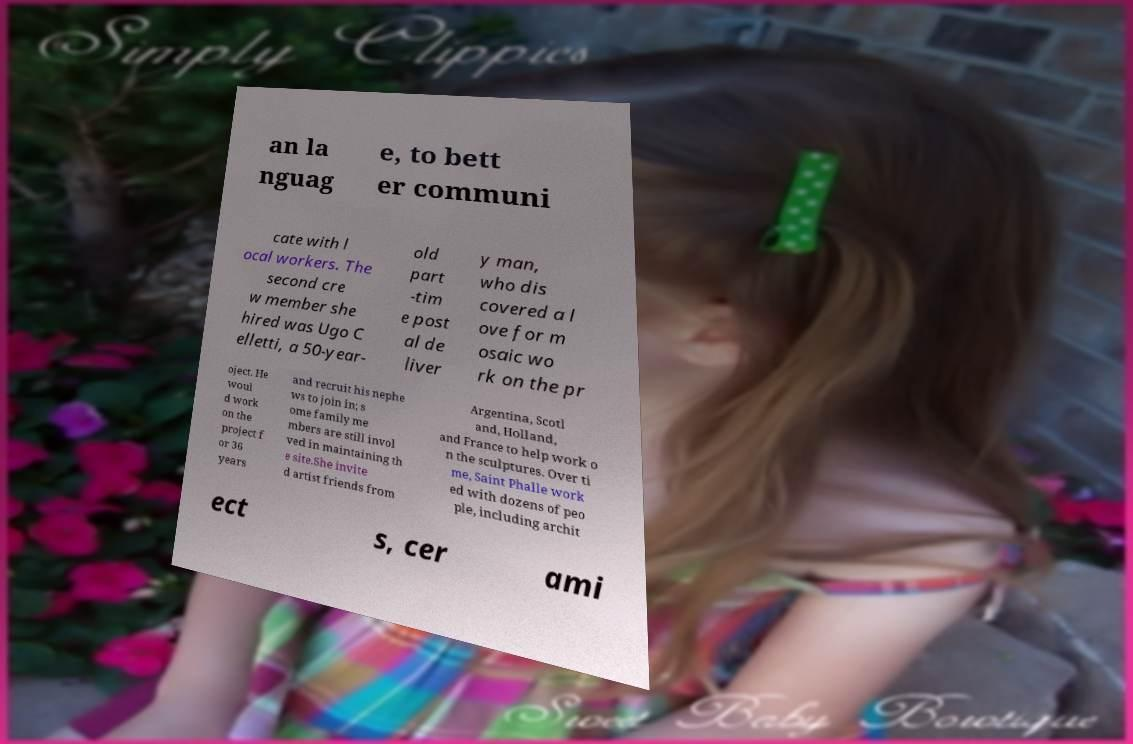Could you assist in decoding the text presented in this image and type it out clearly? an la nguag e, to bett er communi cate with l ocal workers. The second cre w member she hired was Ugo C elletti, a 50-year- old part -tim e post al de liver y man, who dis covered a l ove for m osaic wo rk on the pr oject. He woul d work on the project f or 36 years and recruit his nephe ws to join in; s ome family me mbers are still invol ved in maintaining th e site.She invite d artist friends from Argentina, Scotl and, Holland, and France to help work o n the sculptures. Over ti me, Saint Phalle work ed with dozens of peo ple, including archit ect s, cer ami 